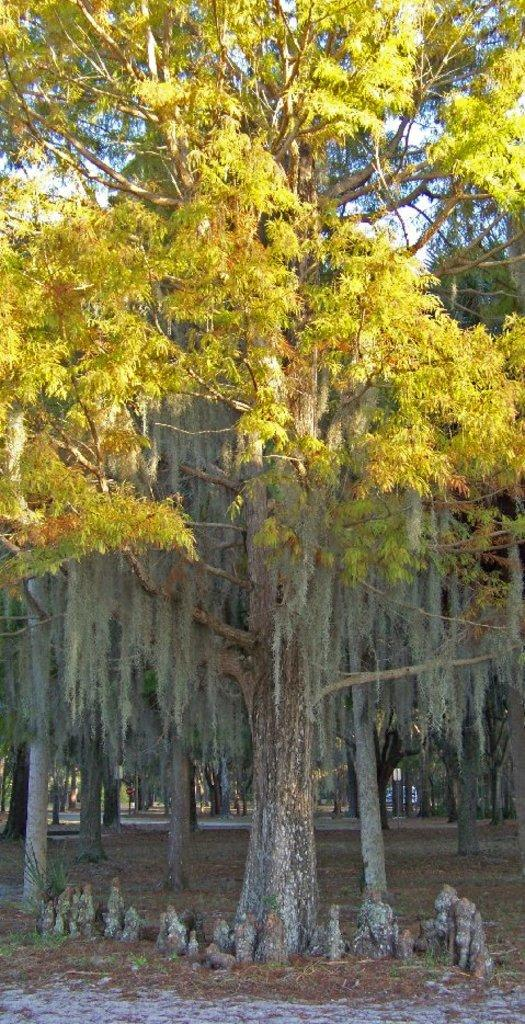What is the setting of the image? The image is an outside view. What type of natural elements can be seen in the image? There are many trees on the ground in the image. How does the snake increase its speed in the image? There is no snake present in the image, so it cannot be determined how it might increase its speed. 